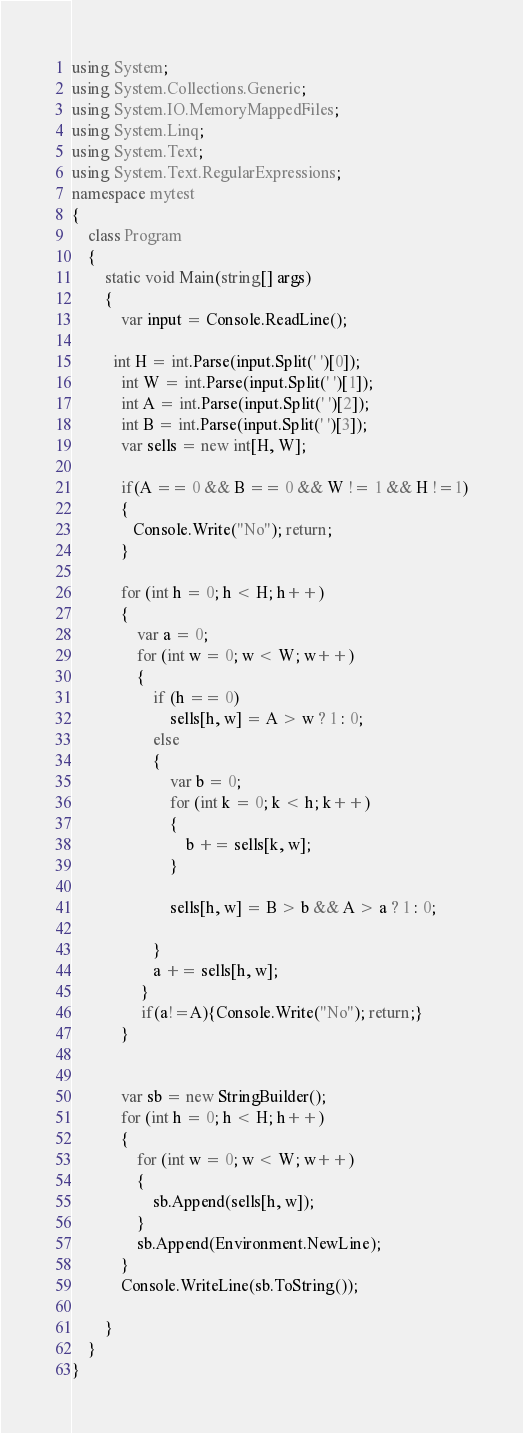<code> <loc_0><loc_0><loc_500><loc_500><_C#_>using System;
using System.Collections.Generic;
using System.IO.MemoryMappedFiles;
using System.Linq;
using System.Text;
using System.Text.RegularExpressions;
namespace mytest
{
    class Program
    {
        static void Main(string[] args)
        {
            var input = Console.ReadLine();
            
          int H = int.Parse(input.Split(' ')[0]);
            int W = int.Parse(input.Split(' ')[1]);
            int A = int.Parse(input.Split(' ')[2]);
            int B = int.Parse(input.Split(' ')[3]);
            var sells = new int[H, W];

            if(A == 0 && B == 0 && W != 1 && H !=1)
            {
               Console.Write("No"); return;
            }
          
            for (int h = 0; h < H; h++)
            {
                var a = 0;
                for (int w = 0; w < W; w++)
                {
                    if (h == 0)
                        sells[h, w] = A > w ? 1 : 0;
                    else
                    {
                        var b = 0;
                        for (int k = 0; k < h; k++)
                        {
                            b += sells[k, w];
                        }

                        sells[h, w] = B > b && A > a ? 1 : 0;

                    }
                    a += sells[h, w];
                 }
                 if(a!=A){Console.Write("No"); return;}
            }


            var sb = new StringBuilder();
            for (int h = 0; h < H; h++)
            {
                for (int w = 0; w < W; w++)
                {
                    sb.Append(sells[h, w]);
                }
                sb.Append(Environment.NewLine);
            }
            Console.WriteLine(sb.ToString());

        }
    }
}
</code> 